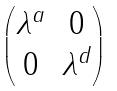<formula> <loc_0><loc_0><loc_500><loc_500>\begin{pmatrix} \lambda ^ { a } & 0 \\ 0 & \lambda ^ { d } \end{pmatrix}</formula> 